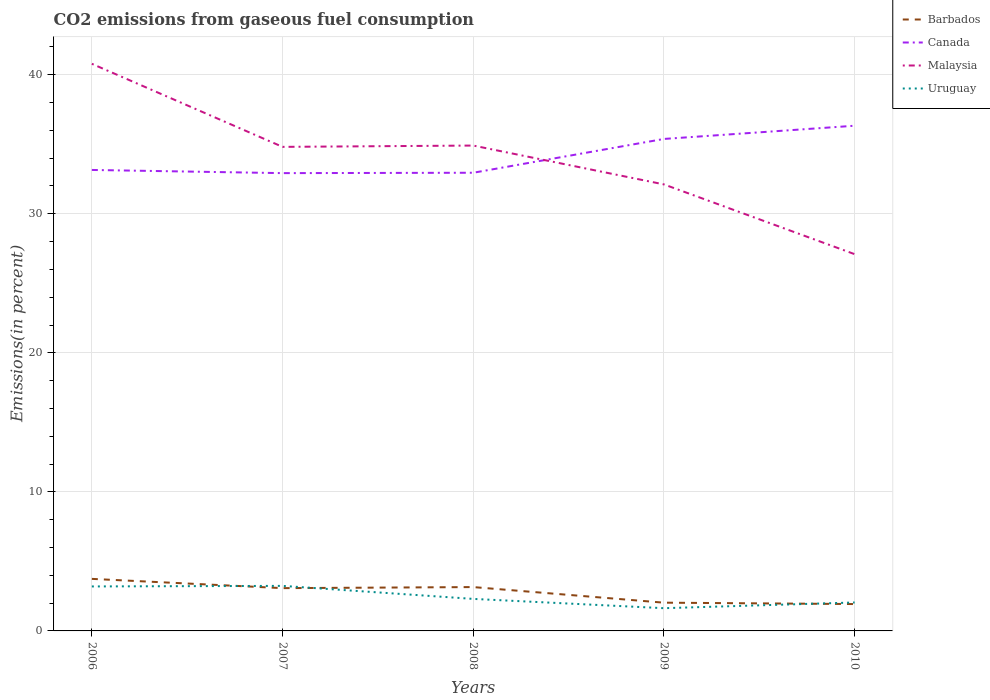How many different coloured lines are there?
Ensure brevity in your answer.  4. Across all years, what is the maximum total CO2 emitted in Uruguay?
Ensure brevity in your answer.  1.63. In which year was the total CO2 emitted in Barbados maximum?
Keep it short and to the point. 2010. What is the total total CO2 emitted in Uruguay in the graph?
Your answer should be compact. 1.56. What is the difference between the highest and the second highest total CO2 emitted in Canada?
Your answer should be very brief. 3.41. Is the total CO2 emitted in Malaysia strictly greater than the total CO2 emitted in Barbados over the years?
Provide a short and direct response. No. How many lines are there?
Your response must be concise. 4. How many years are there in the graph?
Provide a succinct answer. 5. Does the graph contain any zero values?
Provide a succinct answer. No. Does the graph contain grids?
Give a very brief answer. Yes. Where does the legend appear in the graph?
Your answer should be compact. Top right. What is the title of the graph?
Keep it short and to the point. CO2 emissions from gaseous fuel consumption. What is the label or title of the X-axis?
Keep it short and to the point. Years. What is the label or title of the Y-axis?
Offer a terse response. Emissions(in percent). What is the Emissions(in percent) in Barbados in 2006?
Provide a succinct answer. 3.74. What is the Emissions(in percent) in Canada in 2006?
Provide a short and direct response. 33.15. What is the Emissions(in percent) in Malaysia in 2006?
Offer a very short reply. 40.79. What is the Emissions(in percent) of Uruguay in 2006?
Your answer should be compact. 3.2. What is the Emissions(in percent) of Barbados in 2007?
Provide a succinct answer. 3.08. What is the Emissions(in percent) in Canada in 2007?
Make the answer very short. 32.92. What is the Emissions(in percent) in Malaysia in 2007?
Keep it short and to the point. 34.81. What is the Emissions(in percent) of Uruguay in 2007?
Your response must be concise. 3.24. What is the Emissions(in percent) in Barbados in 2008?
Offer a very short reply. 3.15. What is the Emissions(in percent) in Canada in 2008?
Make the answer very short. 32.95. What is the Emissions(in percent) in Malaysia in 2008?
Ensure brevity in your answer.  34.91. What is the Emissions(in percent) of Uruguay in 2008?
Make the answer very short. 2.3. What is the Emissions(in percent) in Barbados in 2009?
Provide a succinct answer. 2.03. What is the Emissions(in percent) in Canada in 2009?
Keep it short and to the point. 35.38. What is the Emissions(in percent) in Malaysia in 2009?
Give a very brief answer. 32.11. What is the Emissions(in percent) in Uruguay in 2009?
Keep it short and to the point. 1.63. What is the Emissions(in percent) in Barbados in 2010?
Provide a succinct answer. 1.93. What is the Emissions(in percent) in Canada in 2010?
Your answer should be very brief. 36.33. What is the Emissions(in percent) in Malaysia in 2010?
Offer a terse response. 27.1. What is the Emissions(in percent) of Uruguay in 2010?
Provide a short and direct response. 2.05. Across all years, what is the maximum Emissions(in percent) of Barbados?
Your response must be concise. 3.74. Across all years, what is the maximum Emissions(in percent) in Canada?
Your answer should be compact. 36.33. Across all years, what is the maximum Emissions(in percent) in Malaysia?
Your answer should be very brief. 40.79. Across all years, what is the maximum Emissions(in percent) in Uruguay?
Provide a short and direct response. 3.24. Across all years, what is the minimum Emissions(in percent) of Barbados?
Provide a short and direct response. 1.93. Across all years, what is the minimum Emissions(in percent) in Canada?
Offer a terse response. 32.92. Across all years, what is the minimum Emissions(in percent) in Malaysia?
Offer a very short reply. 27.1. Across all years, what is the minimum Emissions(in percent) in Uruguay?
Offer a terse response. 1.63. What is the total Emissions(in percent) of Barbados in the graph?
Provide a succinct answer. 13.94. What is the total Emissions(in percent) in Canada in the graph?
Keep it short and to the point. 170.75. What is the total Emissions(in percent) of Malaysia in the graph?
Give a very brief answer. 169.72. What is the total Emissions(in percent) in Uruguay in the graph?
Provide a short and direct response. 12.42. What is the difference between the Emissions(in percent) in Barbados in 2006 and that in 2007?
Provide a succinct answer. 0.67. What is the difference between the Emissions(in percent) of Canada in 2006 and that in 2007?
Provide a short and direct response. 0.23. What is the difference between the Emissions(in percent) of Malaysia in 2006 and that in 2007?
Give a very brief answer. 5.97. What is the difference between the Emissions(in percent) of Uruguay in 2006 and that in 2007?
Your answer should be compact. -0.04. What is the difference between the Emissions(in percent) of Barbados in 2006 and that in 2008?
Keep it short and to the point. 0.59. What is the difference between the Emissions(in percent) of Canada in 2006 and that in 2008?
Offer a very short reply. 0.2. What is the difference between the Emissions(in percent) of Malaysia in 2006 and that in 2008?
Provide a short and direct response. 5.88. What is the difference between the Emissions(in percent) in Uruguay in 2006 and that in 2008?
Make the answer very short. 0.9. What is the difference between the Emissions(in percent) in Barbados in 2006 and that in 2009?
Provide a succinct answer. 1.71. What is the difference between the Emissions(in percent) of Canada in 2006 and that in 2009?
Provide a succinct answer. -2.23. What is the difference between the Emissions(in percent) in Malaysia in 2006 and that in 2009?
Offer a very short reply. 8.67. What is the difference between the Emissions(in percent) in Uruguay in 2006 and that in 2009?
Provide a short and direct response. 1.56. What is the difference between the Emissions(in percent) in Barbados in 2006 and that in 2010?
Your answer should be compact. 1.81. What is the difference between the Emissions(in percent) of Canada in 2006 and that in 2010?
Your response must be concise. -3.18. What is the difference between the Emissions(in percent) of Malaysia in 2006 and that in 2010?
Provide a short and direct response. 13.69. What is the difference between the Emissions(in percent) in Uruguay in 2006 and that in 2010?
Your response must be concise. 1.15. What is the difference between the Emissions(in percent) of Barbados in 2007 and that in 2008?
Offer a very short reply. -0.08. What is the difference between the Emissions(in percent) in Canada in 2007 and that in 2008?
Give a very brief answer. -0.03. What is the difference between the Emissions(in percent) of Malaysia in 2007 and that in 2008?
Keep it short and to the point. -0.09. What is the difference between the Emissions(in percent) of Uruguay in 2007 and that in 2008?
Make the answer very short. 0.94. What is the difference between the Emissions(in percent) of Barbados in 2007 and that in 2009?
Your response must be concise. 1.05. What is the difference between the Emissions(in percent) in Canada in 2007 and that in 2009?
Make the answer very short. -2.46. What is the difference between the Emissions(in percent) in Malaysia in 2007 and that in 2009?
Provide a short and direct response. 2.7. What is the difference between the Emissions(in percent) of Uruguay in 2007 and that in 2009?
Provide a succinct answer. 1.6. What is the difference between the Emissions(in percent) of Barbados in 2007 and that in 2010?
Make the answer very short. 1.14. What is the difference between the Emissions(in percent) of Canada in 2007 and that in 2010?
Make the answer very short. -3.41. What is the difference between the Emissions(in percent) in Malaysia in 2007 and that in 2010?
Offer a terse response. 7.72. What is the difference between the Emissions(in percent) of Uruguay in 2007 and that in 2010?
Your answer should be compact. 1.19. What is the difference between the Emissions(in percent) in Barbados in 2008 and that in 2009?
Your answer should be compact. 1.12. What is the difference between the Emissions(in percent) of Canada in 2008 and that in 2009?
Offer a terse response. -2.43. What is the difference between the Emissions(in percent) in Malaysia in 2008 and that in 2009?
Provide a succinct answer. 2.79. What is the difference between the Emissions(in percent) of Uruguay in 2008 and that in 2009?
Offer a very short reply. 0.67. What is the difference between the Emissions(in percent) in Barbados in 2008 and that in 2010?
Your answer should be compact. 1.22. What is the difference between the Emissions(in percent) of Canada in 2008 and that in 2010?
Offer a very short reply. -3.38. What is the difference between the Emissions(in percent) of Malaysia in 2008 and that in 2010?
Your response must be concise. 7.81. What is the difference between the Emissions(in percent) of Uruguay in 2008 and that in 2010?
Ensure brevity in your answer.  0.26. What is the difference between the Emissions(in percent) in Barbados in 2009 and that in 2010?
Make the answer very short. 0.1. What is the difference between the Emissions(in percent) of Canada in 2009 and that in 2010?
Offer a terse response. -0.95. What is the difference between the Emissions(in percent) of Malaysia in 2009 and that in 2010?
Provide a succinct answer. 5.02. What is the difference between the Emissions(in percent) in Uruguay in 2009 and that in 2010?
Ensure brevity in your answer.  -0.41. What is the difference between the Emissions(in percent) in Barbados in 2006 and the Emissions(in percent) in Canada in 2007?
Your answer should be compact. -29.18. What is the difference between the Emissions(in percent) of Barbados in 2006 and the Emissions(in percent) of Malaysia in 2007?
Ensure brevity in your answer.  -31.07. What is the difference between the Emissions(in percent) of Barbados in 2006 and the Emissions(in percent) of Uruguay in 2007?
Make the answer very short. 0.5. What is the difference between the Emissions(in percent) of Canada in 2006 and the Emissions(in percent) of Malaysia in 2007?
Make the answer very short. -1.66. What is the difference between the Emissions(in percent) of Canada in 2006 and the Emissions(in percent) of Uruguay in 2007?
Your response must be concise. 29.91. What is the difference between the Emissions(in percent) of Malaysia in 2006 and the Emissions(in percent) of Uruguay in 2007?
Ensure brevity in your answer.  37.55. What is the difference between the Emissions(in percent) of Barbados in 2006 and the Emissions(in percent) of Canada in 2008?
Ensure brevity in your answer.  -29.21. What is the difference between the Emissions(in percent) of Barbados in 2006 and the Emissions(in percent) of Malaysia in 2008?
Offer a terse response. -31.16. What is the difference between the Emissions(in percent) in Barbados in 2006 and the Emissions(in percent) in Uruguay in 2008?
Offer a terse response. 1.44. What is the difference between the Emissions(in percent) of Canada in 2006 and the Emissions(in percent) of Malaysia in 2008?
Your answer should be compact. -1.75. What is the difference between the Emissions(in percent) in Canada in 2006 and the Emissions(in percent) in Uruguay in 2008?
Your answer should be very brief. 30.85. What is the difference between the Emissions(in percent) of Malaysia in 2006 and the Emissions(in percent) of Uruguay in 2008?
Your answer should be very brief. 38.48. What is the difference between the Emissions(in percent) in Barbados in 2006 and the Emissions(in percent) in Canada in 2009?
Your answer should be very brief. -31.64. What is the difference between the Emissions(in percent) of Barbados in 2006 and the Emissions(in percent) of Malaysia in 2009?
Your response must be concise. -28.37. What is the difference between the Emissions(in percent) of Barbados in 2006 and the Emissions(in percent) of Uruguay in 2009?
Provide a succinct answer. 2.11. What is the difference between the Emissions(in percent) in Canada in 2006 and the Emissions(in percent) in Malaysia in 2009?
Make the answer very short. 1.04. What is the difference between the Emissions(in percent) in Canada in 2006 and the Emissions(in percent) in Uruguay in 2009?
Your answer should be compact. 31.52. What is the difference between the Emissions(in percent) in Malaysia in 2006 and the Emissions(in percent) in Uruguay in 2009?
Provide a short and direct response. 39.15. What is the difference between the Emissions(in percent) in Barbados in 2006 and the Emissions(in percent) in Canada in 2010?
Give a very brief answer. -32.59. What is the difference between the Emissions(in percent) of Barbados in 2006 and the Emissions(in percent) of Malaysia in 2010?
Your response must be concise. -23.35. What is the difference between the Emissions(in percent) in Barbados in 2006 and the Emissions(in percent) in Uruguay in 2010?
Your answer should be very brief. 1.7. What is the difference between the Emissions(in percent) in Canada in 2006 and the Emissions(in percent) in Malaysia in 2010?
Make the answer very short. 6.06. What is the difference between the Emissions(in percent) of Canada in 2006 and the Emissions(in percent) of Uruguay in 2010?
Offer a very short reply. 31.11. What is the difference between the Emissions(in percent) in Malaysia in 2006 and the Emissions(in percent) in Uruguay in 2010?
Give a very brief answer. 38.74. What is the difference between the Emissions(in percent) in Barbados in 2007 and the Emissions(in percent) in Canada in 2008?
Your answer should be very brief. -29.87. What is the difference between the Emissions(in percent) in Barbados in 2007 and the Emissions(in percent) in Malaysia in 2008?
Provide a succinct answer. -31.83. What is the difference between the Emissions(in percent) of Barbados in 2007 and the Emissions(in percent) of Uruguay in 2008?
Your answer should be very brief. 0.77. What is the difference between the Emissions(in percent) in Canada in 2007 and the Emissions(in percent) in Malaysia in 2008?
Your answer should be very brief. -1.98. What is the difference between the Emissions(in percent) of Canada in 2007 and the Emissions(in percent) of Uruguay in 2008?
Provide a succinct answer. 30.62. What is the difference between the Emissions(in percent) in Malaysia in 2007 and the Emissions(in percent) in Uruguay in 2008?
Keep it short and to the point. 32.51. What is the difference between the Emissions(in percent) in Barbados in 2007 and the Emissions(in percent) in Canada in 2009?
Offer a very short reply. -32.31. What is the difference between the Emissions(in percent) of Barbados in 2007 and the Emissions(in percent) of Malaysia in 2009?
Give a very brief answer. -29.04. What is the difference between the Emissions(in percent) in Barbados in 2007 and the Emissions(in percent) in Uruguay in 2009?
Offer a very short reply. 1.44. What is the difference between the Emissions(in percent) in Canada in 2007 and the Emissions(in percent) in Malaysia in 2009?
Your answer should be compact. 0.81. What is the difference between the Emissions(in percent) in Canada in 2007 and the Emissions(in percent) in Uruguay in 2009?
Give a very brief answer. 31.29. What is the difference between the Emissions(in percent) in Malaysia in 2007 and the Emissions(in percent) in Uruguay in 2009?
Ensure brevity in your answer.  33.18. What is the difference between the Emissions(in percent) in Barbados in 2007 and the Emissions(in percent) in Canada in 2010?
Make the answer very short. -33.26. What is the difference between the Emissions(in percent) in Barbados in 2007 and the Emissions(in percent) in Malaysia in 2010?
Ensure brevity in your answer.  -24.02. What is the difference between the Emissions(in percent) of Barbados in 2007 and the Emissions(in percent) of Uruguay in 2010?
Your response must be concise. 1.03. What is the difference between the Emissions(in percent) of Canada in 2007 and the Emissions(in percent) of Malaysia in 2010?
Provide a succinct answer. 5.83. What is the difference between the Emissions(in percent) of Canada in 2007 and the Emissions(in percent) of Uruguay in 2010?
Your response must be concise. 30.88. What is the difference between the Emissions(in percent) in Malaysia in 2007 and the Emissions(in percent) in Uruguay in 2010?
Your response must be concise. 32.77. What is the difference between the Emissions(in percent) of Barbados in 2008 and the Emissions(in percent) of Canada in 2009?
Your response must be concise. -32.23. What is the difference between the Emissions(in percent) of Barbados in 2008 and the Emissions(in percent) of Malaysia in 2009?
Offer a very short reply. -28.96. What is the difference between the Emissions(in percent) in Barbados in 2008 and the Emissions(in percent) in Uruguay in 2009?
Provide a succinct answer. 1.52. What is the difference between the Emissions(in percent) in Canada in 2008 and the Emissions(in percent) in Malaysia in 2009?
Provide a short and direct response. 0.84. What is the difference between the Emissions(in percent) in Canada in 2008 and the Emissions(in percent) in Uruguay in 2009?
Offer a terse response. 31.32. What is the difference between the Emissions(in percent) of Malaysia in 2008 and the Emissions(in percent) of Uruguay in 2009?
Provide a succinct answer. 33.27. What is the difference between the Emissions(in percent) in Barbados in 2008 and the Emissions(in percent) in Canada in 2010?
Your answer should be very brief. -33.18. What is the difference between the Emissions(in percent) of Barbados in 2008 and the Emissions(in percent) of Malaysia in 2010?
Your answer should be compact. -23.94. What is the difference between the Emissions(in percent) of Barbados in 2008 and the Emissions(in percent) of Uruguay in 2010?
Your response must be concise. 1.11. What is the difference between the Emissions(in percent) in Canada in 2008 and the Emissions(in percent) in Malaysia in 2010?
Your answer should be very brief. 5.85. What is the difference between the Emissions(in percent) of Canada in 2008 and the Emissions(in percent) of Uruguay in 2010?
Ensure brevity in your answer.  30.91. What is the difference between the Emissions(in percent) of Malaysia in 2008 and the Emissions(in percent) of Uruguay in 2010?
Keep it short and to the point. 32.86. What is the difference between the Emissions(in percent) in Barbados in 2009 and the Emissions(in percent) in Canada in 2010?
Your answer should be compact. -34.3. What is the difference between the Emissions(in percent) in Barbados in 2009 and the Emissions(in percent) in Malaysia in 2010?
Offer a terse response. -25.07. What is the difference between the Emissions(in percent) in Barbados in 2009 and the Emissions(in percent) in Uruguay in 2010?
Provide a succinct answer. -0.01. What is the difference between the Emissions(in percent) of Canada in 2009 and the Emissions(in percent) of Malaysia in 2010?
Give a very brief answer. 8.29. What is the difference between the Emissions(in percent) of Canada in 2009 and the Emissions(in percent) of Uruguay in 2010?
Your answer should be compact. 33.34. What is the difference between the Emissions(in percent) of Malaysia in 2009 and the Emissions(in percent) of Uruguay in 2010?
Offer a very short reply. 30.07. What is the average Emissions(in percent) of Barbados per year?
Provide a short and direct response. 2.79. What is the average Emissions(in percent) in Canada per year?
Give a very brief answer. 34.15. What is the average Emissions(in percent) in Malaysia per year?
Keep it short and to the point. 33.94. What is the average Emissions(in percent) in Uruguay per year?
Provide a short and direct response. 2.48. In the year 2006, what is the difference between the Emissions(in percent) in Barbados and Emissions(in percent) in Canada?
Offer a terse response. -29.41. In the year 2006, what is the difference between the Emissions(in percent) in Barbados and Emissions(in percent) in Malaysia?
Keep it short and to the point. -37.04. In the year 2006, what is the difference between the Emissions(in percent) in Barbados and Emissions(in percent) in Uruguay?
Your answer should be compact. 0.54. In the year 2006, what is the difference between the Emissions(in percent) of Canada and Emissions(in percent) of Malaysia?
Offer a very short reply. -7.63. In the year 2006, what is the difference between the Emissions(in percent) in Canada and Emissions(in percent) in Uruguay?
Offer a very short reply. 29.95. In the year 2006, what is the difference between the Emissions(in percent) of Malaysia and Emissions(in percent) of Uruguay?
Offer a terse response. 37.59. In the year 2007, what is the difference between the Emissions(in percent) of Barbados and Emissions(in percent) of Canada?
Make the answer very short. -29.85. In the year 2007, what is the difference between the Emissions(in percent) of Barbados and Emissions(in percent) of Malaysia?
Give a very brief answer. -31.74. In the year 2007, what is the difference between the Emissions(in percent) in Barbados and Emissions(in percent) in Uruguay?
Offer a terse response. -0.16. In the year 2007, what is the difference between the Emissions(in percent) in Canada and Emissions(in percent) in Malaysia?
Provide a succinct answer. -1.89. In the year 2007, what is the difference between the Emissions(in percent) in Canada and Emissions(in percent) in Uruguay?
Give a very brief answer. 29.68. In the year 2007, what is the difference between the Emissions(in percent) of Malaysia and Emissions(in percent) of Uruguay?
Ensure brevity in your answer.  31.57. In the year 2008, what is the difference between the Emissions(in percent) in Barbados and Emissions(in percent) in Canada?
Provide a short and direct response. -29.8. In the year 2008, what is the difference between the Emissions(in percent) of Barbados and Emissions(in percent) of Malaysia?
Keep it short and to the point. -31.75. In the year 2008, what is the difference between the Emissions(in percent) of Barbados and Emissions(in percent) of Uruguay?
Provide a succinct answer. 0.85. In the year 2008, what is the difference between the Emissions(in percent) of Canada and Emissions(in percent) of Malaysia?
Offer a very short reply. -1.96. In the year 2008, what is the difference between the Emissions(in percent) of Canada and Emissions(in percent) of Uruguay?
Ensure brevity in your answer.  30.65. In the year 2008, what is the difference between the Emissions(in percent) of Malaysia and Emissions(in percent) of Uruguay?
Offer a very short reply. 32.6. In the year 2009, what is the difference between the Emissions(in percent) of Barbados and Emissions(in percent) of Canada?
Your response must be concise. -33.35. In the year 2009, what is the difference between the Emissions(in percent) in Barbados and Emissions(in percent) in Malaysia?
Ensure brevity in your answer.  -30.08. In the year 2009, what is the difference between the Emissions(in percent) in Barbados and Emissions(in percent) in Uruguay?
Provide a short and direct response. 0.4. In the year 2009, what is the difference between the Emissions(in percent) in Canada and Emissions(in percent) in Malaysia?
Provide a succinct answer. 3.27. In the year 2009, what is the difference between the Emissions(in percent) in Canada and Emissions(in percent) in Uruguay?
Your answer should be very brief. 33.75. In the year 2009, what is the difference between the Emissions(in percent) of Malaysia and Emissions(in percent) of Uruguay?
Your answer should be very brief. 30.48. In the year 2010, what is the difference between the Emissions(in percent) of Barbados and Emissions(in percent) of Canada?
Make the answer very short. -34.4. In the year 2010, what is the difference between the Emissions(in percent) in Barbados and Emissions(in percent) in Malaysia?
Offer a very short reply. -25.16. In the year 2010, what is the difference between the Emissions(in percent) of Barbados and Emissions(in percent) of Uruguay?
Offer a very short reply. -0.11. In the year 2010, what is the difference between the Emissions(in percent) in Canada and Emissions(in percent) in Malaysia?
Make the answer very short. 9.24. In the year 2010, what is the difference between the Emissions(in percent) of Canada and Emissions(in percent) of Uruguay?
Keep it short and to the point. 34.29. In the year 2010, what is the difference between the Emissions(in percent) of Malaysia and Emissions(in percent) of Uruguay?
Provide a short and direct response. 25.05. What is the ratio of the Emissions(in percent) in Barbados in 2006 to that in 2007?
Give a very brief answer. 1.22. What is the ratio of the Emissions(in percent) of Canada in 2006 to that in 2007?
Make the answer very short. 1.01. What is the ratio of the Emissions(in percent) of Malaysia in 2006 to that in 2007?
Your response must be concise. 1.17. What is the ratio of the Emissions(in percent) of Uruguay in 2006 to that in 2007?
Give a very brief answer. 0.99. What is the ratio of the Emissions(in percent) of Barbados in 2006 to that in 2008?
Ensure brevity in your answer.  1.19. What is the ratio of the Emissions(in percent) in Canada in 2006 to that in 2008?
Make the answer very short. 1.01. What is the ratio of the Emissions(in percent) in Malaysia in 2006 to that in 2008?
Give a very brief answer. 1.17. What is the ratio of the Emissions(in percent) of Uruguay in 2006 to that in 2008?
Ensure brevity in your answer.  1.39. What is the ratio of the Emissions(in percent) in Barbados in 2006 to that in 2009?
Your answer should be very brief. 1.84. What is the ratio of the Emissions(in percent) in Canada in 2006 to that in 2009?
Keep it short and to the point. 0.94. What is the ratio of the Emissions(in percent) in Malaysia in 2006 to that in 2009?
Ensure brevity in your answer.  1.27. What is the ratio of the Emissions(in percent) in Uruguay in 2006 to that in 2009?
Provide a succinct answer. 1.96. What is the ratio of the Emissions(in percent) in Barbados in 2006 to that in 2010?
Keep it short and to the point. 1.94. What is the ratio of the Emissions(in percent) in Canada in 2006 to that in 2010?
Give a very brief answer. 0.91. What is the ratio of the Emissions(in percent) of Malaysia in 2006 to that in 2010?
Give a very brief answer. 1.51. What is the ratio of the Emissions(in percent) in Uruguay in 2006 to that in 2010?
Offer a very short reply. 1.56. What is the ratio of the Emissions(in percent) of Barbados in 2007 to that in 2008?
Ensure brevity in your answer.  0.98. What is the ratio of the Emissions(in percent) of Canada in 2007 to that in 2008?
Your answer should be compact. 1. What is the ratio of the Emissions(in percent) of Malaysia in 2007 to that in 2008?
Provide a short and direct response. 1. What is the ratio of the Emissions(in percent) of Uruguay in 2007 to that in 2008?
Offer a very short reply. 1.41. What is the ratio of the Emissions(in percent) in Barbados in 2007 to that in 2009?
Offer a very short reply. 1.51. What is the ratio of the Emissions(in percent) of Canada in 2007 to that in 2009?
Provide a short and direct response. 0.93. What is the ratio of the Emissions(in percent) in Malaysia in 2007 to that in 2009?
Keep it short and to the point. 1.08. What is the ratio of the Emissions(in percent) in Uruguay in 2007 to that in 2009?
Give a very brief answer. 1.98. What is the ratio of the Emissions(in percent) of Barbados in 2007 to that in 2010?
Provide a short and direct response. 1.59. What is the ratio of the Emissions(in percent) in Canada in 2007 to that in 2010?
Give a very brief answer. 0.91. What is the ratio of the Emissions(in percent) of Malaysia in 2007 to that in 2010?
Offer a very short reply. 1.28. What is the ratio of the Emissions(in percent) of Uruguay in 2007 to that in 2010?
Give a very brief answer. 1.58. What is the ratio of the Emissions(in percent) of Barbados in 2008 to that in 2009?
Offer a very short reply. 1.55. What is the ratio of the Emissions(in percent) in Canada in 2008 to that in 2009?
Your answer should be very brief. 0.93. What is the ratio of the Emissions(in percent) of Malaysia in 2008 to that in 2009?
Your response must be concise. 1.09. What is the ratio of the Emissions(in percent) in Uruguay in 2008 to that in 2009?
Keep it short and to the point. 1.41. What is the ratio of the Emissions(in percent) in Barbados in 2008 to that in 2010?
Your answer should be very brief. 1.63. What is the ratio of the Emissions(in percent) of Canada in 2008 to that in 2010?
Provide a short and direct response. 0.91. What is the ratio of the Emissions(in percent) in Malaysia in 2008 to that in 2010?
Make the answer very short. 1.29. What is the ratio of the Emissions(in percent) in Uruguay in 2008 to that in 2010?
Give a very brief answer. 1.13. What is the ratio of the Emissions(in percent) in Barbados in 2009 to that in 2010?
Keep it short and to the point. 1.05. What is the ratio of the Emissions(in percent) in Canada in 2009 to that in 2010?
Offer a terse response. 0.97. What is the ratio of the Emissions(in percent) of Malaysia in 2009 to that in 2010?
Provide a succinct answer. 1.19. What is the ratio of the Emissions(in percent) in Uruguay in 2009 to that in 2010?
Keep it short and to the point. 0.8. What is the difference between the highest and the second highest Emissions(in percent) of Barbados?
Provide a succinct answer. 0.59. What is the difference between the highest and the second highest Emissions(in percent) in Canada?
Your answer should be very brief. 0.95. What is the difference between the highest and the second highest Emissions(in percent) of Malaysia?
Provide a succinct answer. 5.88. What is the difference between the highest and the second highest Emissions(in percent) in Uruguay?
Your response must be concise. 0.04. What is the difference between the highest and the lowest Emissions(in percent) in Barbados?
Offer a very short reply. 1.81. What is the difference between the highest and the lowest Emissions(in percent) of Canada?
Your response must be concise. 3.41. What is the difference between the highest and the lowest Emissions(in percent) of Malaysia?
Your answer should be compact. 13.69. What is the difference between the highest and the lowest Emissions(in percent) in Uruguay?
Make the answer very short. 1.6. 